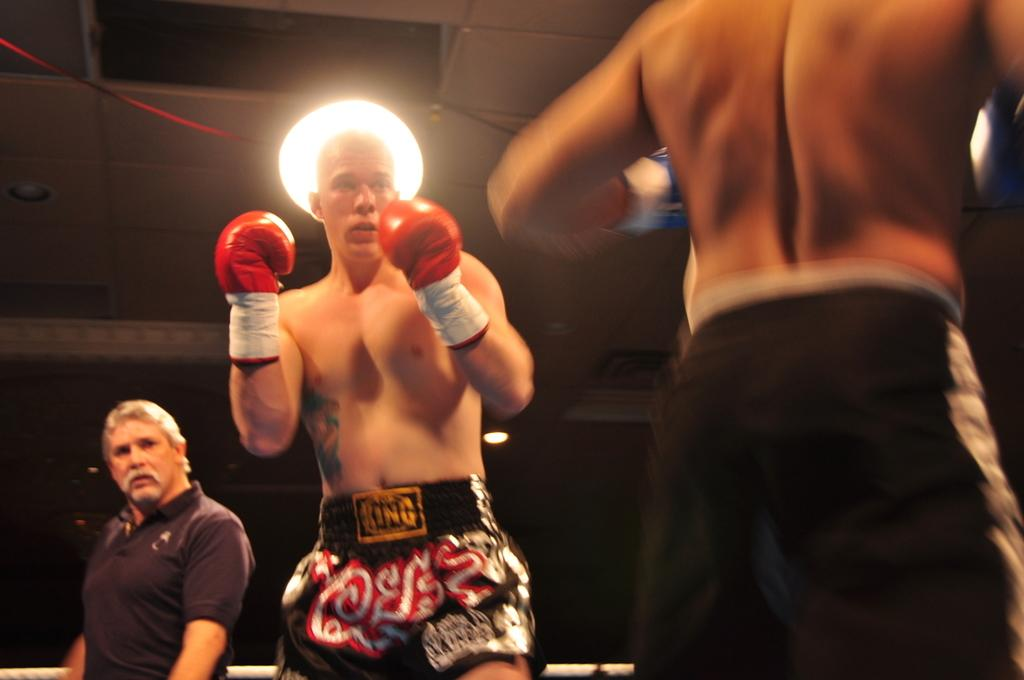What is the person in the foreground of the image wearing on their hands? The person is wearing gloves in the image. Can you describe the person in the background of the image? There is another person in the background of the image. What is the source of illumination in the image? There is light in the image. How would you describe the overall lighting conditions in the image? The background of the image is dark. What type of curtain is hanging from the ceiling in the image? There is no curtain present in the image. What type of skirt is the person in the image wearing? The person in the image is wearing gloves, not a skirt. 